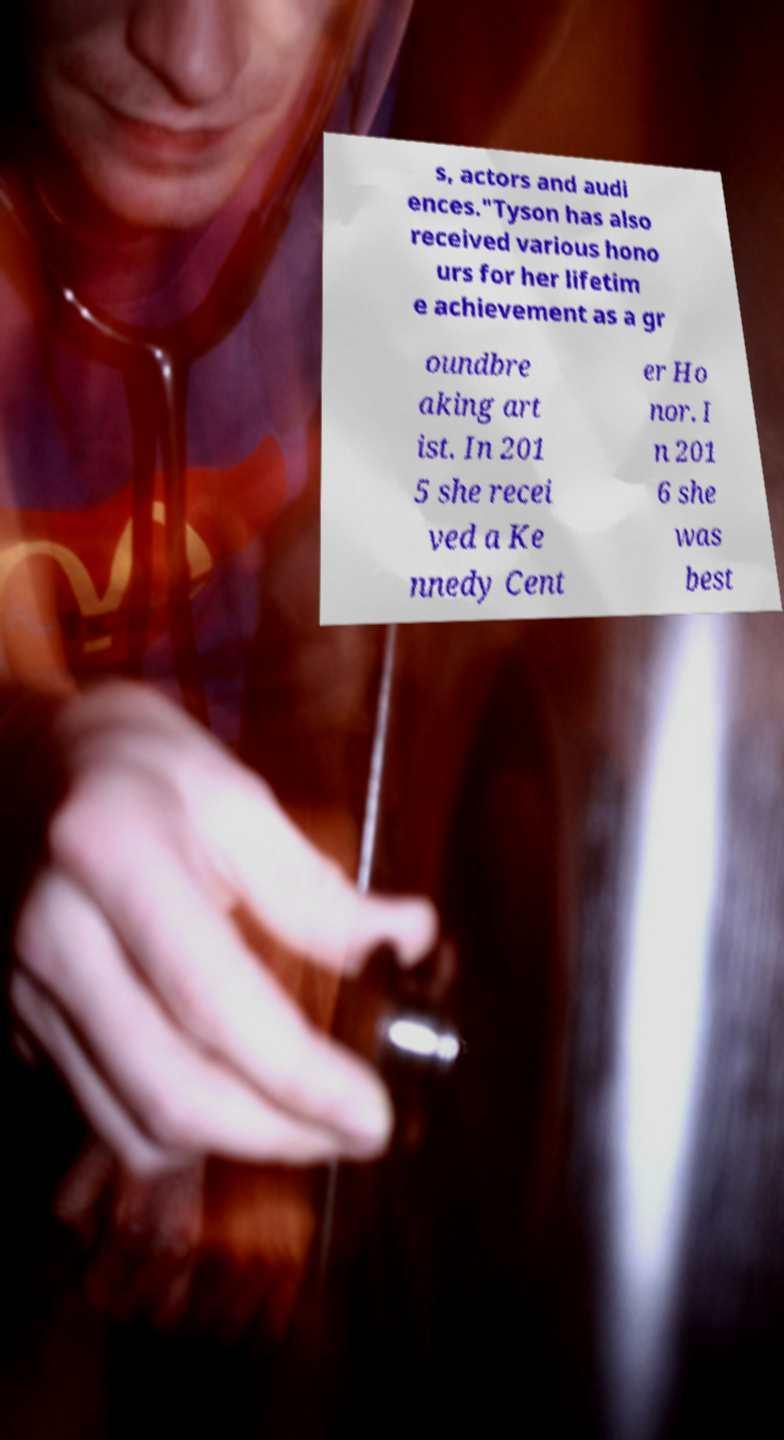Please read and relay the text visible in this image. What does it say? s, actors and audi ences."Tyson has also received various hono urs for her lifetim e achievement as a gr oundbre aking art ist. In 201 5 she recei ved a Ke nnedy Cent er Ho nor. I n 201 6 she was best 